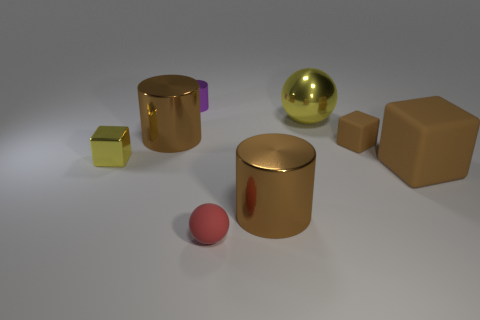Subtract all brown cylinders. How many cylinders are left? 1 Add 1 big yellow things. How many objects exist? 9 Subtract all purple blocks. How many brown cylinders are left? 2 Subtract all red balls. How many balls are left? 1 Subtract all blocks. How many objects are left? 5 Subtract all gray rubber cubes. Subtract all red objects. How many objects are left? 7 Add 6 tiny metallic blocks. How many tiny metallic blocks are left? 7 Add 2 yellow metallic cubes. How many yellow metallic cubes exist? 3 Subtract 0 blue spheres. How many objects are left? 8 Subtract all blue cylinders. Subtract all purple cubes. How many cylinders are left? 3 